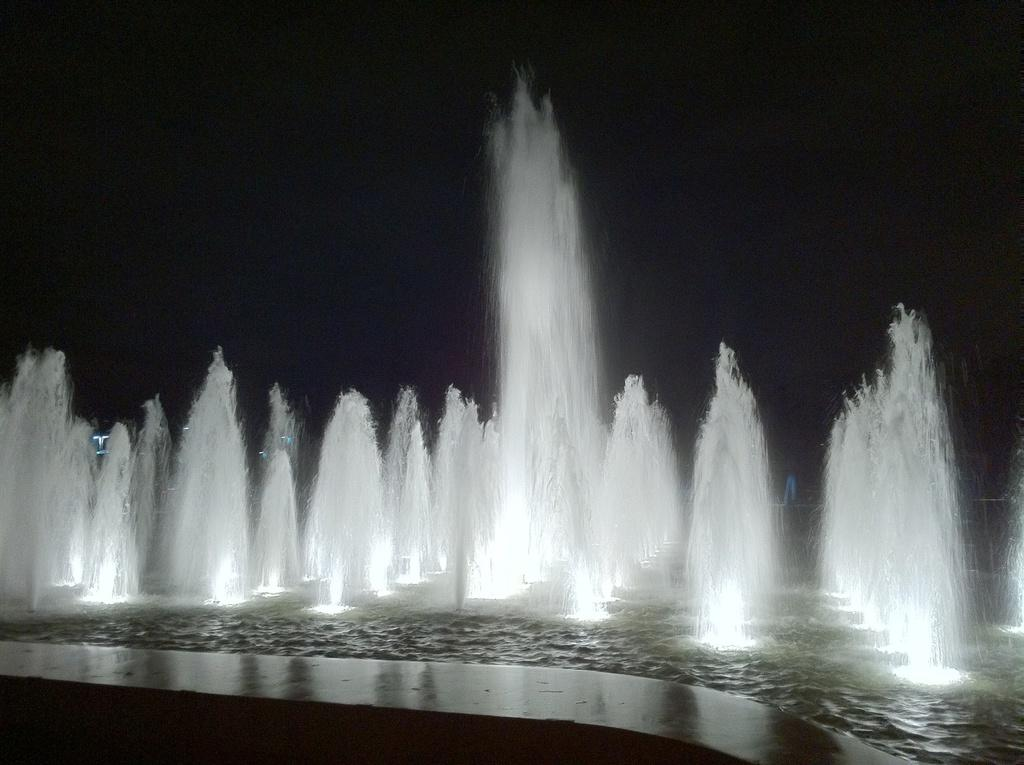What is present in the image that is related to water? There are fountains in the image. What can be seen in the sky in the image? The sky is visible at the top of the image. How does the overall appearance of the image come across? The image appears to be dark. Can you feel the steam coming from the water in the image? There is no steam present in the image, so it cannot be felt. What company is responsible for the fountains in the image? The image does not provide information about the company responsible for the fountains. 